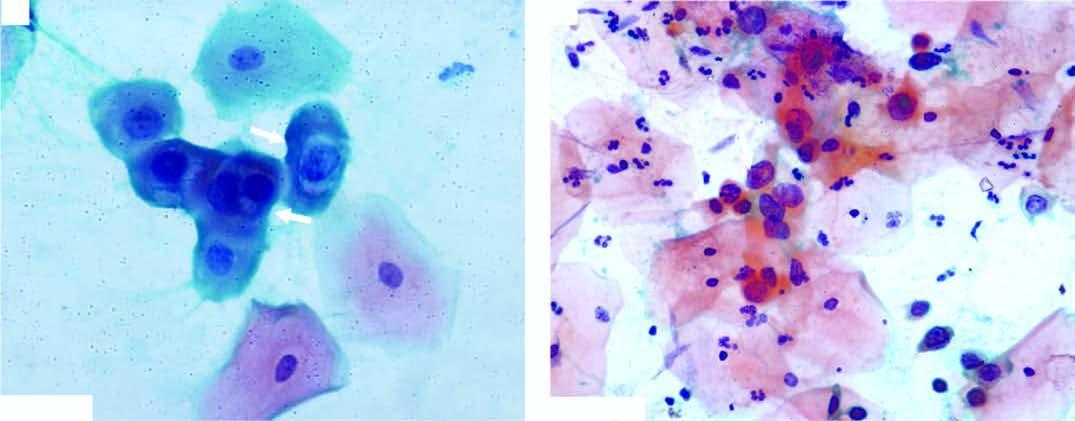does the covering mucosa show koilocytes having abundant vacuolated cytoplasm and nuclear enlargement arrow?
Answer the question using a single word or phrase. No 